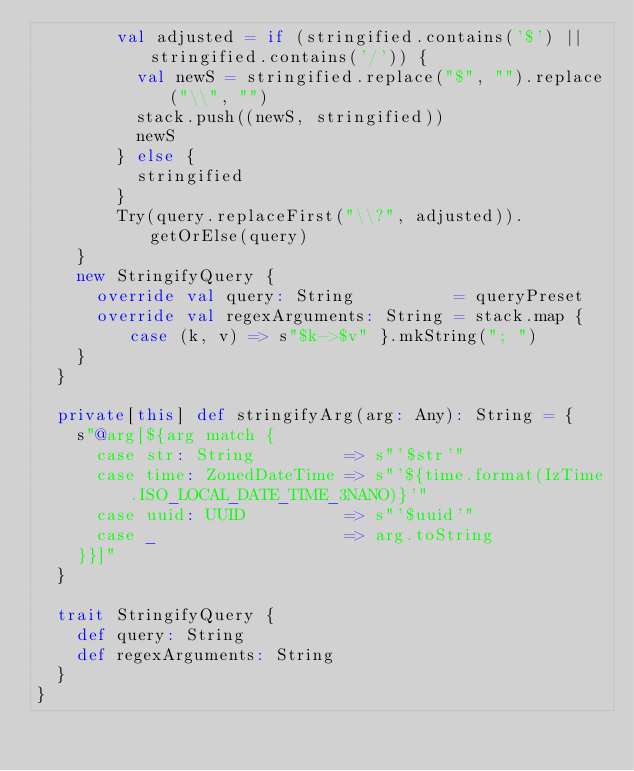Convert code to text. <code><loc_0><loc_0><loc_500><loc_500><_Scala_>        val adjusted = if (stringified.contains('$') || stringified.contains('/')) {
          val newS = stringified.replace("$", "").replace("\\", "")
          stack.push((newS, stringified))
          newS
        } else {
          stringified
        }
        Try(query.replaceFirst("\\?", adjusted)).getOrElse(query)
    }
    new StringifyQuery {
      override val query: String          = queryPreset
      override val regexArguments: String = stack.map { case (k, v) => s"$k->$v" }.mkString("; ")
    }
  }

  private[this] def stringifyArg(arg: Any): String = {
    s"@arg[${arg match {
      case str: String         => s"'$str'"
      case time: ZonedDateTime => s"'${time.format(IzTime.ISO_LOCAL_DATE_TIME_3NANO)}'"
      case uuid: UUID          => s"'$uuid'"
      case _                   => arg.toString
    }}]"
  }

  trait StringifyQuery {
    def query: String
    def regexArguments: String
  }
}
</code> 